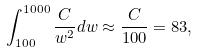Convert formula to latex. <formula><loc_0><loc_0><loc_500><loc_500>\int _ { 1 0 0 } ^ { 1 0 0 0 } \frac { C } { w ^ { 2 } } d w \approx \frac { C } { 1 0 0 } = 8 3 ,</formula> 